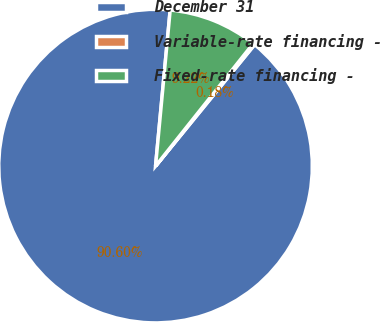Convert chart to OTSL. <chart><loc_0><loc_0><loc_500><loc_500><pie_chart><fcel>December 31<fcel>Variable-rate financing -<fcel>Fixed-rate financing -<nl><fcel>90.6%<fcel>0.18%<fcel>9.22%<nl></chart> 